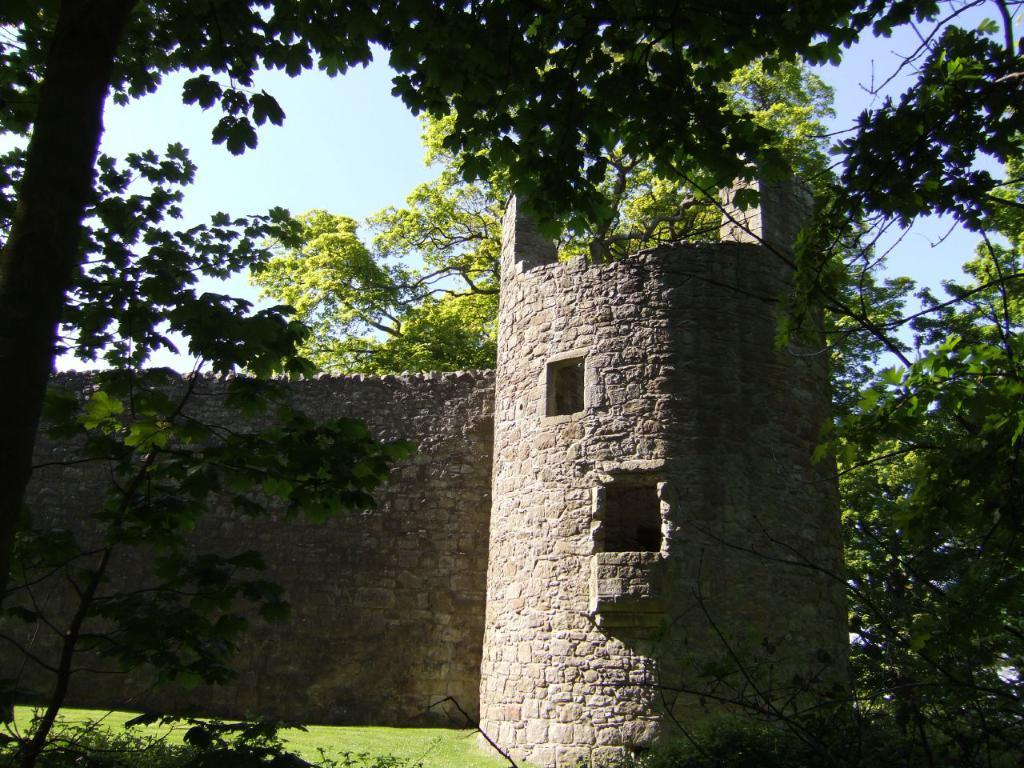What type of vegetation is in the front of the image? There are plants in the front of the image. What is on the ground in the center of the image? There is grass on the ground in the center of the image. What structure is in the center of the image? There is a pillar in the center of the image. What can be seen in the background of the image? There is a wall and trees in the background of the image. What type of pest can be seen crawling on the pillar in the image? There is no pest visible on the pillar in the image. What color is the silver object in the image? There is no silver object present in the image. 